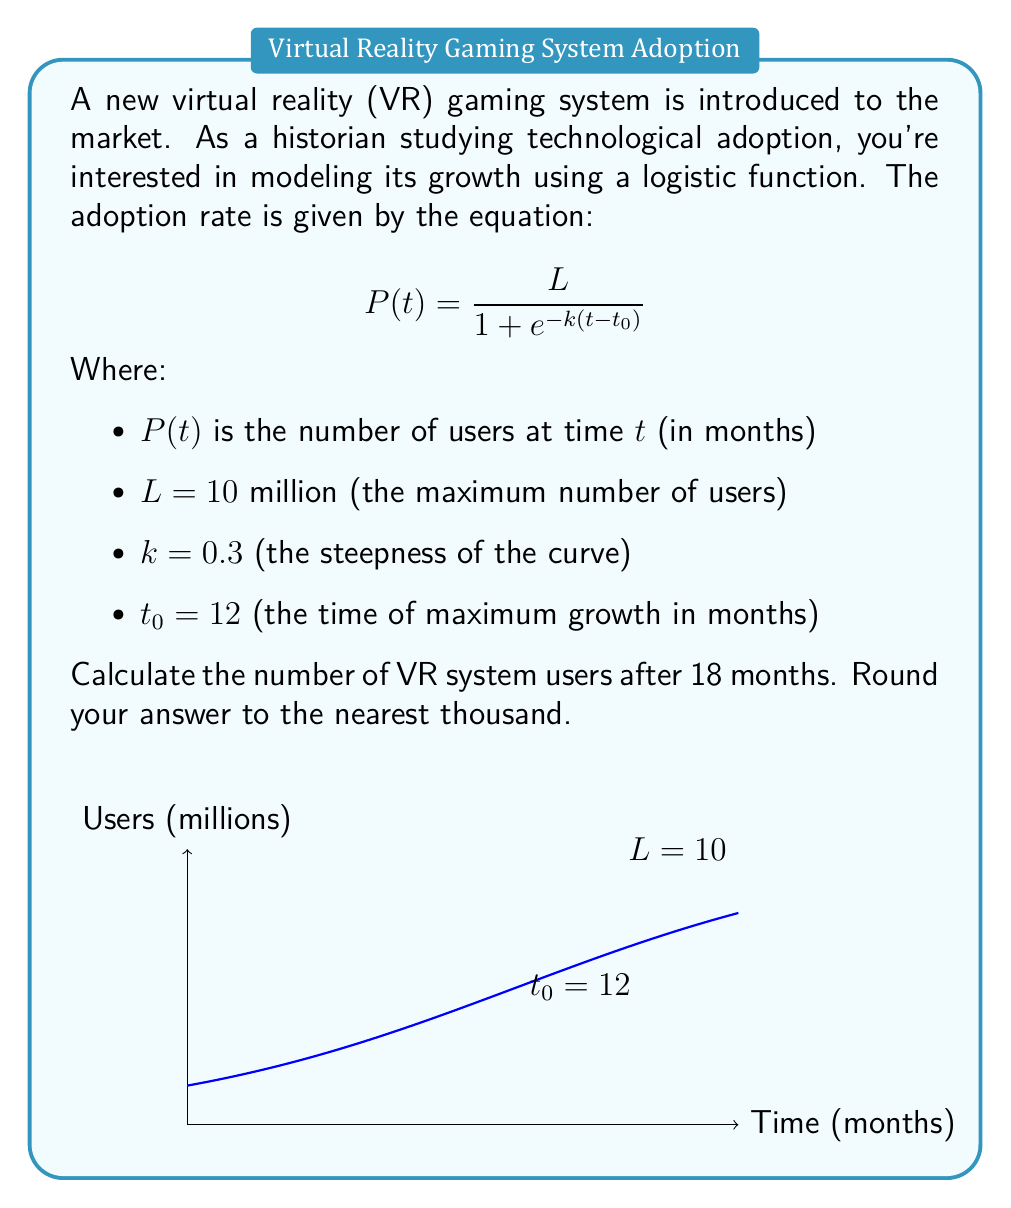Teach me how to tackle this problem. To solve this problem, we'll follow these steps:

1) We're given the logistic growth function:
   $$ P(t) = \frac{L}{1 + e^{-k(t-t_0)}} $$

2) We know the values:
   $L = 10$ million
   $k = 0.3$
   $t_0 = 12$ months
   $t = 18$ months (the time we're interested in)

3) Let's substitute these values into the equation:
   $$ P(18) = \frac{10}{1 + e^{-0.3(18-12)}} $$

4) Simplify the exponent:
   $$ P(18) = \frac{10}{1 + e^{-0.3(6)}} = \frac{10}{1 + e^{-1.8}} $$

5) Calculate $e^{-1.8}$:
   $e^{-1.8} \approx 0.1653$

6) Substitute this value:
   $$ P(18) = \frac{10}{1 + 0.1653} = \frac{10}{1.1653} $$

7) Divide:
   $$ P(18) \approx 8.5815 \text{ million} $$

8) Rounding to the nearest thousand:
   $8.5815$ million $\approx 8,582,000$ users

This result shows that after 18 months, the VR system would have approximately 8,582,000 users according to this logistic growth model.
Answer: 8,582,000 users 